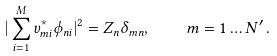<formula> <loc_0><loc_0><loc_500><loc_500>| \sum _ { i = 1 } ^ { M } v _ { m i } ^ { \ast } \phi _ { n i } | ^ { 2 } = Z _ { n } \delta _ { m n } , \quad m = 1 \dots N ^ { \prime } \, .</formula> 